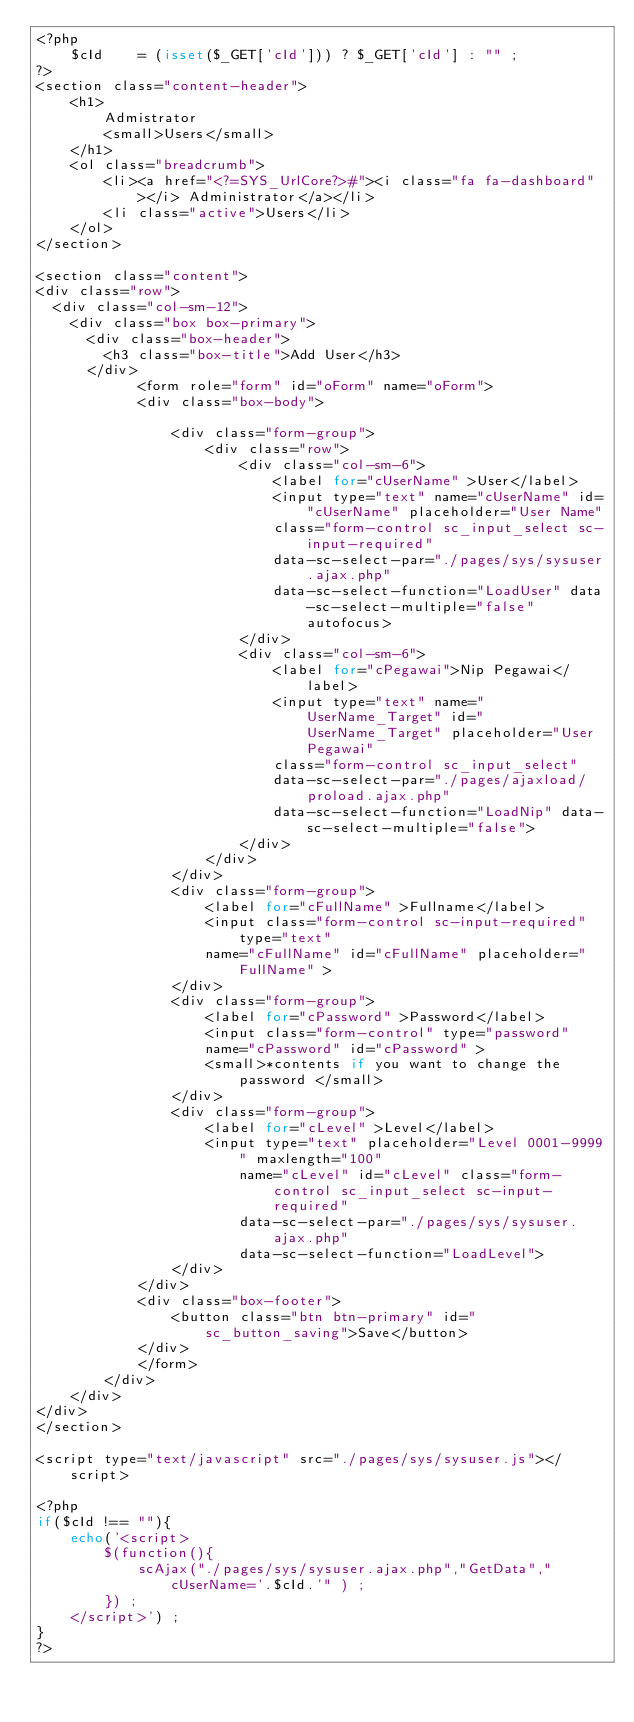Convert code to text. <code><loc_0><loc_0><loc_500><loc_500><_PHP_><?php 
    $cId    = (isset($_GET['cId'])) ? $_GET['cId'] : "" ; 
?>
<section class="content-header">
    <h1>
        Admistrator
        <small>Users</small>
    </h1>
    <ol class="breadcrumb">
        <li><a href="<?=SYS_UrlCore?>#"><i class="fa fa-dashboard"></i> Administrator</a></li>
        <li class="active">Users</li> 
    </ol> 
</section>

<section class="content">
<div class="row">
	<div class="col-sm-12">
		<div class="box box-primary">
			<div class="box-header">
				<h3 class="box-title">Add User</h3>
			</div>   
            <form role="form" id="oForm" name="oForm">
            <div class="box-body"> 
            
                <div class="form-group">  
                    <div class="row">
                        <div class="col-sm-6">
                            <label for="cUserName" >User</label>
                            <input type="text" name="cUserName" id="cUserName" placeholder="User Name"
                            class="form-control sc_input_select sc-input-required" 
                            data-sc-select-par="./pages/sys/sysuser.ajax.php"  
                            data-sc-select-function="LoadUser" data-sc-select-multiple="false" autofocus> 
                        </div>
                        <div class="col-sm-6">
                            <label for="cPegawai">Nip Pegawai</label>
                            <input type="text" name="UserName_Target" id="UserName_Target" placeholder="User Pegawai"
                            class="form-control sc_input_select" 
                            data-sc-select-par="./pages/ajaxload/proload.ajax.php"  
                            data-sc-select-function="LoadNip" data-sc-select-multiple="false"> 
                        </div>
                    </div>
                </div> 
                <div class="form-group">  
                    <label for="cFullName" >Fullname</label>
                    <input class="form-control sc-input-required" type="text" 
                    name="cFullName" id="cFullName" placeholder="FullName" > 
                </div>             
                <div class="form-group">  
                    <label for="cPassword" >Password</label>
                    <input class="form-control" type="password" 
                    name="cPassword" id="cPassword" >  
                    <small>*contents if you want to change the password </small>
                </div>               
                <div class="form-group">  
                    <label for="cLevel" >Level</label>
                    <input type="text" placeholder="Level 0001-9999" maxlength="100"
                        name="cLevel" id="cLevel" class="form-control sc_input_select sc-input-required"
                        data-sc-select-par="./pages/sys/sysuser.ajax.php"  
                        data-sc-select-function="LoadLevel">
                </div>                    
            </div>
            <div class="box-footer">
                <button class="btn btn-primary" id="sc_button_saving">Save</button>
            </div>
            </form>
        </div>
    </div>
</div>
</section>

<script type="text/javascript" src="./pages/sys/sysuser.js"></script>

<?php
if($cId !== ""){
    echo('<script>
        $(function(){ 
            scAjax("./pages/sys/sysuser.ajax.php","GetData","cUserName='.$cId.'" ) ;  
        }) ;  
    </script>') ;  
}
?> </code> 